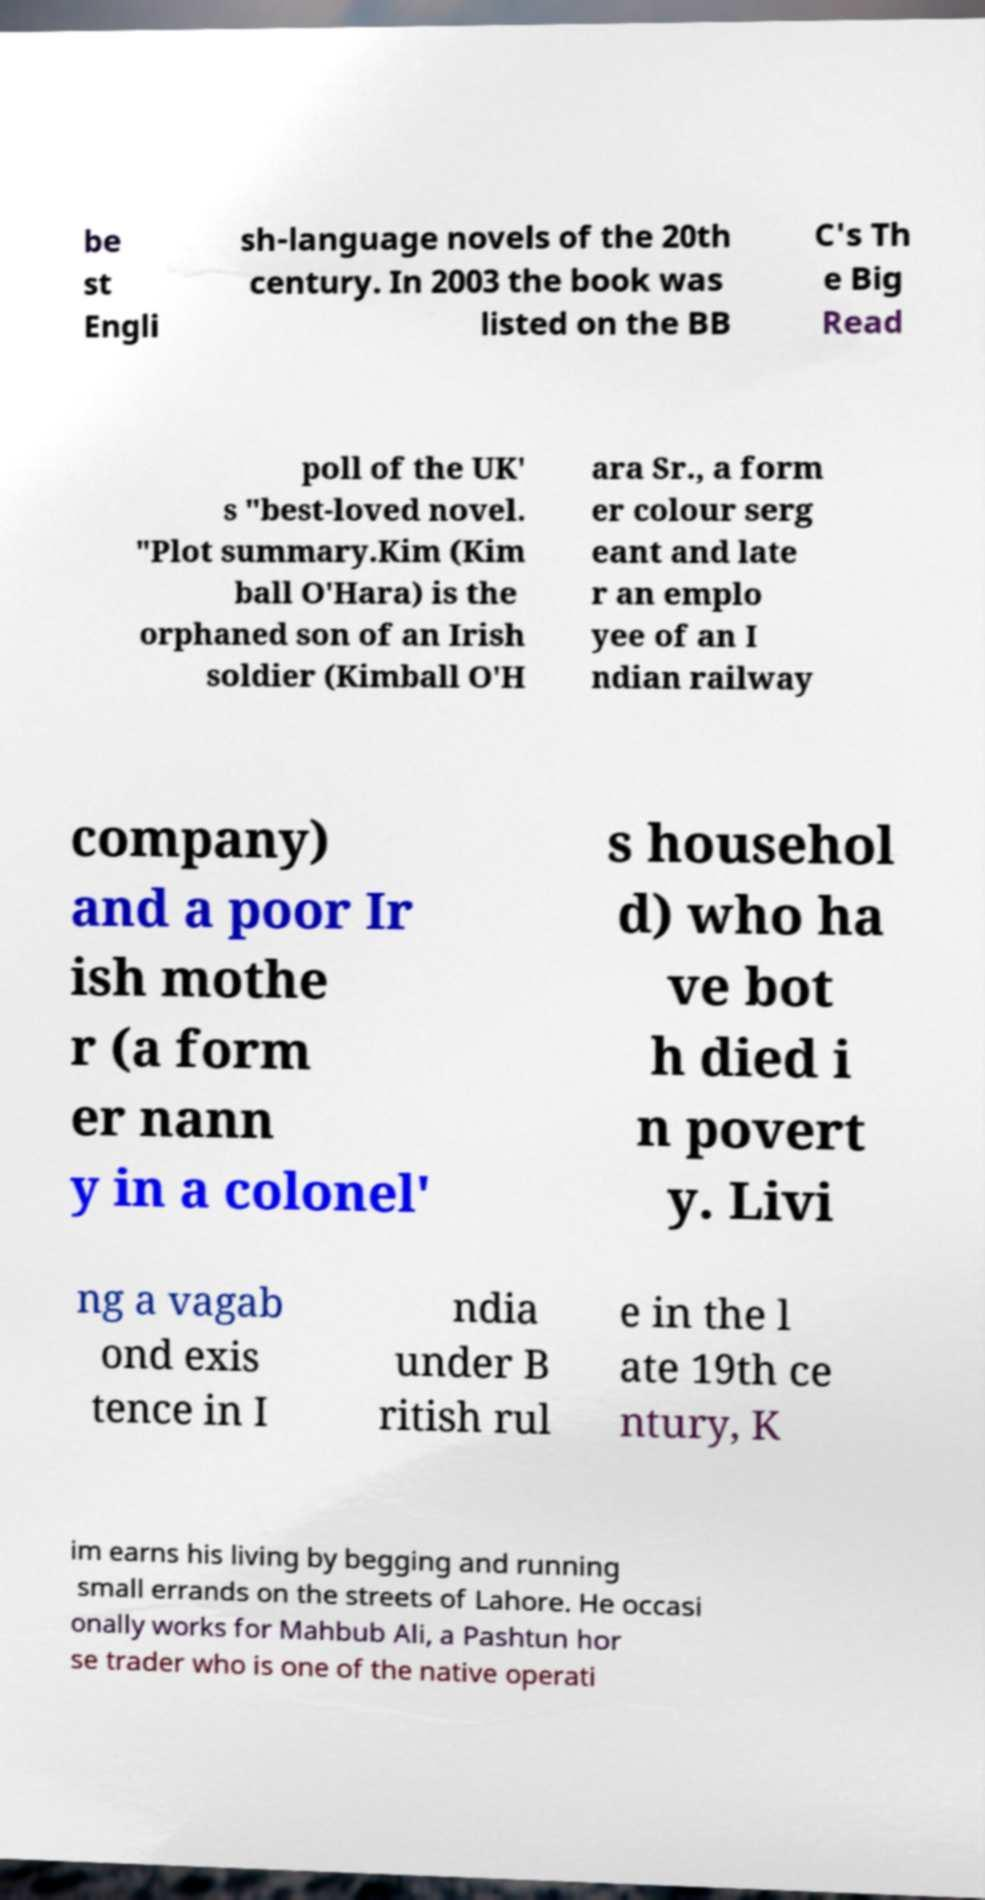Please read and relay the text visible in this image. What does it say? be st Engli sh-language novels of the 20th century. In 2003 the book was listed on the BB C's Th e Big Read poll of the UK' s "best-loved novel. "Plot summary.Kim (Kim ball O'Hara) is the orphaned son of an Irish soldier (Kimball O'H ara Sr., a form er colour serg eant and late r an emplo yee of an I ndian railway company) and a poor Ir ish mothe r (a form er nann y in a colonel' s househol d) who ha ve bot h died i n povert y. Livi ng a vagab ond exis tence in I ndia under B ritish rul e in the l ate 19th ce ntury, K im earns his living by begging and running small errands on the streets of Lahore. He occasi onally works for Mahbub Ali, a Pashtun hor se trader who is one of the native operati 